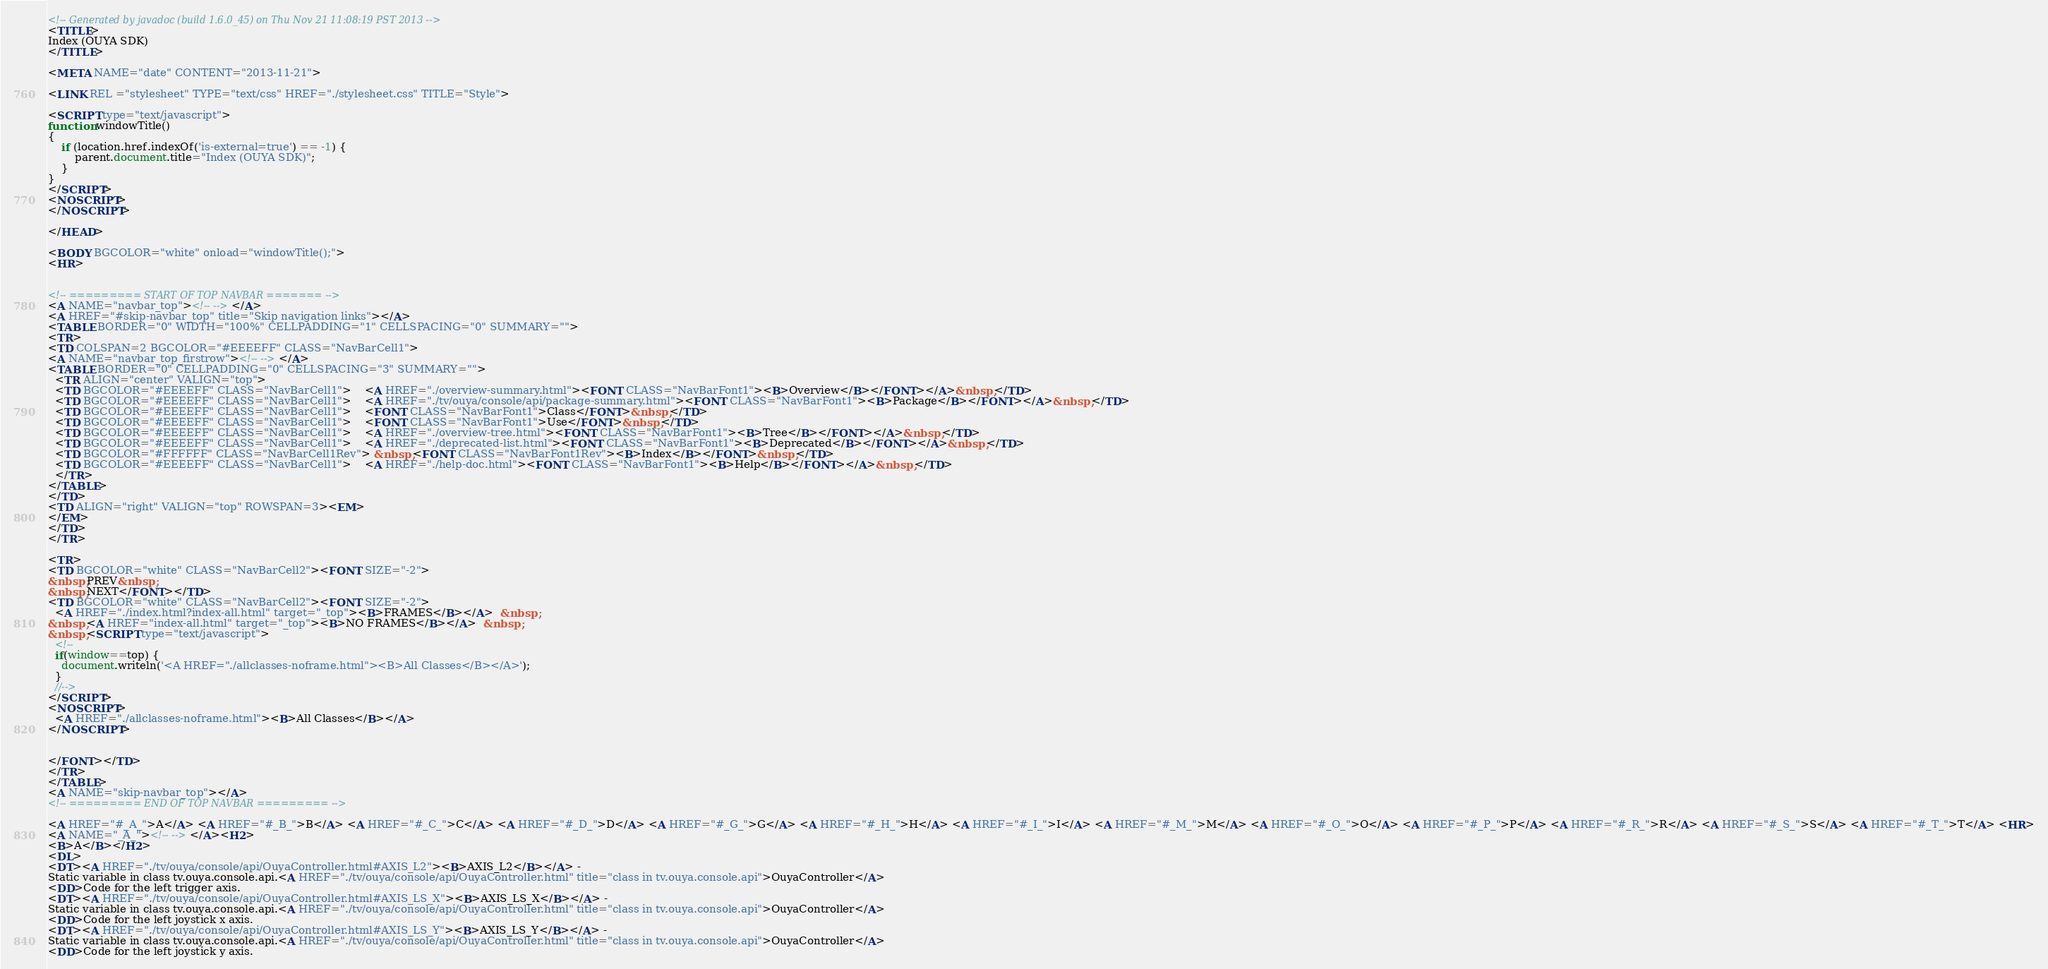Convert code to text. <code><loc_0><loc_0><loc_500><loc_500><_HTML_><!-- Generated by javadoc (build 1.6.0_45) on Thu Nov 21 11:08:19 PST 2013 -->
<TITLE>
Index (OUYA SDK)
</TITLE>

<META NAME="date" CONTENT="2013-11-21">

<LINK REL ="stylesheet" TYPE="text/css" HREF="./stylesheet.css" TITLE="Style">

<SCRIPT type="text/javascript">
function windowTitle()
{
    if (location.href.indexOf('is-external=true') == -1) {
        parent.document.title="Index (OUYA SDK)";
    }
}
</SCRIPT>
<NOSCRIPT>
</NOSCRIPT>

</HEAD>

<BODY BGCOLOR="white" onload="windowTitle();">
<HR>


<!-- ========= START OF TOP NAVBAR ======= -->
<A NAME="navbar_top"><!-- --></A>
<A HREF="#skip-navbar_top" title="Skip navigation links"></A>
<TABLE BORDER="0" WIDTH="100%" CELLPADDING="1" CELLSPACING="0" SUMMARY="">
<TR>
<TD COLSPAN=2 BGCOLOR="#EEEEFF" CLASS="NavBarCell1">
<A NAME="navbar_top_firstrow"><!-- --></A>
<TABLE BORDER="0" CELLPADDING="0" CELLSPACING="3" SUMMARY="">
  <TR ALIGN="center" VALIGN="top">
  <TD BGCOLOR="#EEEEFF" CLASS="NavBarCell1">    <A HREF="./overview-summary.html"><FONT CLASS="NavBarFont1"><B>Overview</B></FONT></A>&nbsp;</TD>
  <TD BGCOLOR="#EEEEFF" CLASS="NavBarCell1">    <A HREF="./tv/ouya/console/api/package-summary.html"><FONT CLASS="NavBarFont1"><B>Package</B></FONT></A>&nbsp;</TD>
  <TD BGCOLOR="#EEEEFF" CLASS="NavBarCell1">    <FONT CLASS="NavBarFont1">Class</FONT>&nbsp;</TD>
  <TD BGCOLOR="#EEEEFF" CLASS="NavBarCell1">    <FONT CLASS="NavBarFont1">Use</FONT>&nbsp;</TD>
  <TD BGCOLOR="#EEEEFF" CLASS="NavBarCell1">    <A HREF="./overview-tree.html"><FONT CLASS="NavBarFont1"><B>Tree</B></FONT></A>&nbsp;</TD>
  <TD BGCOLOR="#EEEEFF" CLASS="NavBarCell1">    <A HREF="./deprecated-list.html"><FONT CLASS="NavBarFont1"><B>Deprecated</B></FONT></A>&nbsp;</TD>
  <TD BGCOLOR="#FFFFFF" CLASS="NavBarCell1Rev"> &nbsp;<FONT CLASS="NavBarFont1Rev"><B>Index</B></FONT>&nbsp;</TD>
  <TD BGCOLOR="#EEEEFF" CLASS="NavBarCell1">    <A HREF="./help-doc.html"><FONT CLASS="NavBarFont1"><B>Help</B></FONT></A>&nbsp;</TD>
  </TR>
</TABLE>
</TD>
<TD ALIGN="right" VALIGN="top" ROWSPAN=3><EM>
</EM>
</TD>
</TR>

<TR>
<TD BGCOLOR="white" CLASS="NavBarCell2"><FONT SIZE="-2">
&nbsp;PREV&nbsp;
&nbsp;NEXT</FONT></TD>
<TD BGCOLOR="white" CLASS="NavBarCell2"><FONT SIZE="-2">
  <A HREF="./index.html?index-all.html" target="_top"><B>FRAMES</B></A>  &nbsp;
&nbsp;<A HREF="index-all.html" target="_top"><B>NO FRAMES</B></A>  &nbsp;
&nbsp;<SCRIPT type="text/javascript">
  <!--
  if(window==top) {
    document.writeln('<A HREF="./allclasses-noframe.html"><B>All Classes</B></A>');
  }
  //-->
</SCRIPT>
<NOSCRIPT>
  <A HREF="./allclasses-noframe.html"><B>All Classes</B></A>
</NOSCRIPT>


</FONT></TD>
</TR>
</TABLE>
<A NAME="skip-navbar_top"></A>
<!-- ========= END OF TOP NAVBAR ========= -->

<A HREF="#_A_">A</A> <A HREF="#_B_">B</A> <A HREF="#_C_">C</A> <A HREF="#_D_">D</A> <A HREF="#_G_">G</A> <A HREF="#_H_">H</A> <A HREF="#_I_">I</A> <A HREF="#_M_">M</A> <A HREF="#_O_">O</A> <A HREF="#_P_">P</A> <A HREF="#_R_">R</A> <A HREF="#_S_">S</A> <A HREF="#_T_">T</A> <HR>
<A NAME="_A_"><!-- --></A><H2>
<B>A</B></H2>
<DL>
<DT><A HREF="./tv/ouya/console/api/OuyaController.html#AXIS_L2"><B>AXIS_L2</B></A> - 
Static variable in class tv.ouya.console.api.<A HREF="./tv/ouya/console/api/OuyaController.html" title="class in tv.ouya.console.api">OuyaController</A>
<DD>Code for the left trigger axis.
<DT><A HREF="./tv/ouya/console/api/OuyaController.html#AXIS_LS_X"><B>AXIS_LS_X</B></A> - 
Static variable in class tv.ouya.console.api.<A HREF="./tv/ouya/console/api/OuyaController.html" title="class in tv.ouya.console.api">OuyaController</A>
<DD>Code for the left joystick x axis.
<DT><A HREF="./tv/ouya/console/api/OuyaController.html#AXIS_LS_Y"><B>AXIS_LS_Y</B></A> - 
Static variable in class tv.ouya.console.api.<A HREF="./tv/ouya/console/api/OuyaController.html" title="class in tv.ouya.console.api">OuyaController</A>
<DD>Code for the left joystick y axis.</code> 